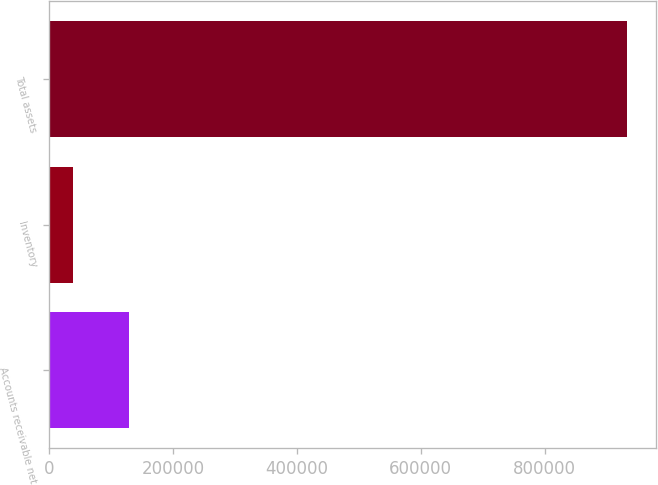Convert chart to OTSL. <chart><loc_0><loc_0><loc_500><loc_500><bar_chart><fcel>Accounts receivable net<fcel>Inventory<fcel>Total assets<nl><fcel>127982<fcel>38446<fcel>933802<nl></chart> 